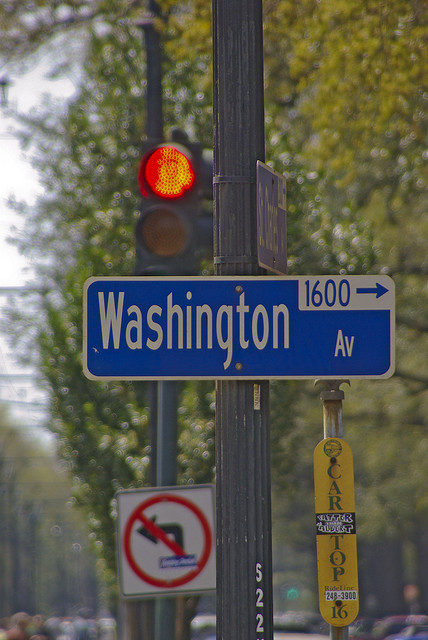Identify the text displayed in this image. Washington AV 1600 CAR TOP 16 248-3900 522 